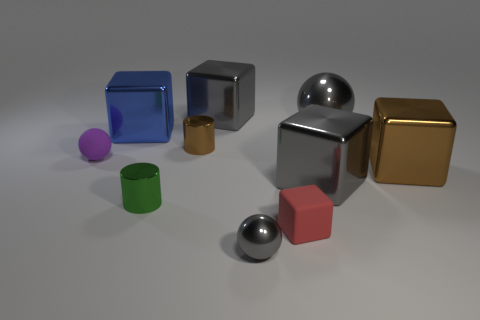What is the red block made of?
Keep it short and to the point. Rubber. There is a gray block right of the tiny gray sphere in front of the metal cylinder that is to the left of the brown shiny cylinder; what size is it?
Ensure brevity in your answer.  Large. What material is the other ball that is the same color as the big ball?
Make the answer very short. Metal. How many shiny objects are purple balls or tiny brown blocks?
Offer a very short reply. 0. The blue thing has what size?
Make the answer very short. Large. What number of things are either small gray objects or cylinders that are behind the purple sphere?
Offer a very short reply. 2. How many other things are the same color as the tiny metal sphere?
Offer a terse response. 3. Do the purple ball and the gray metal cube behind the large blue shiny block have the same size?
Give a very brief answer. No. Does the metallic object to the left of the green cylinder have the same size as the big ball?
Make the answer very short. Yes. How many other things are there of the same material as the small brown cylinder?
Give a very brief answer. 7. 